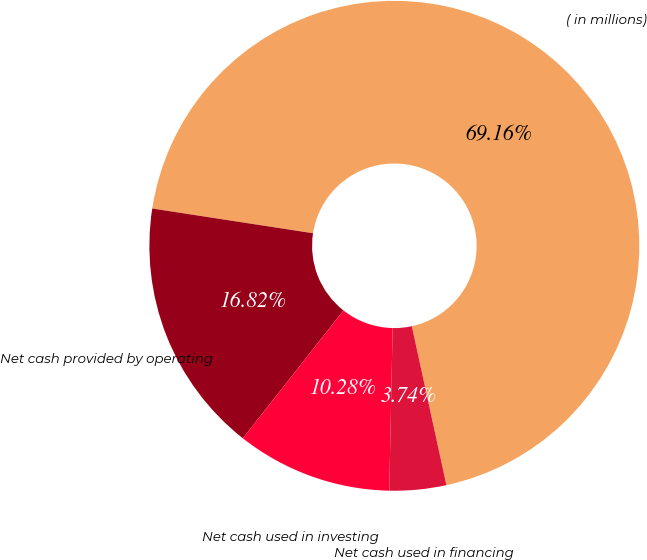<chart> <loc_0><loc_0><loc_500><loc_500><pie_chart><fcel>( in millions)<fcel>Net cash provided by operating<fcel>Net cash used in investing<fcel>Net cash used in financing<nl><fcel>69.16%<fcel>16.82%<fcel>10.28%<fcel>3.74%<nl></chart> 